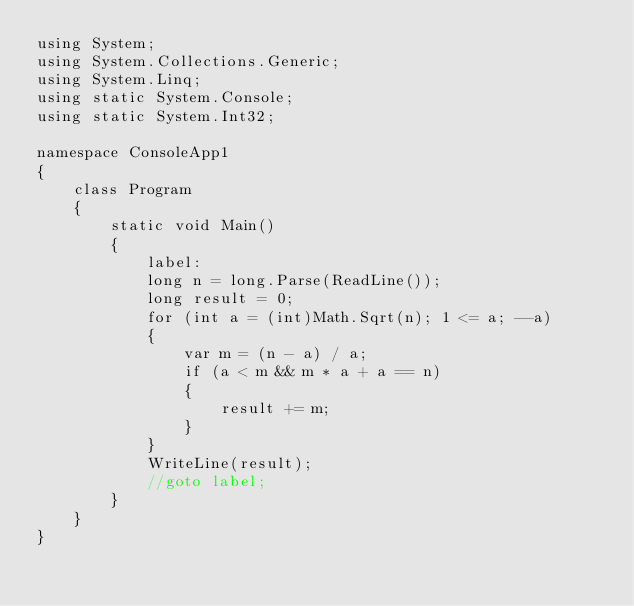<code> <loc_0><loc_0><loc_500><loc_500><_C#_>using System;
using System.Collections.Generic;
using System.Linq;
using static System.Console;
using static System.Int32;

namespace ConsoleApp1
{
    class Program
    {
        static void Main()
        {
            label:
            long n = long.Parse(ReadLine());
            long result = 0;
            for (int a = (int)Math.Sqrt(n); 1 <= a; --a)
            {
                var m = (n - a) / a;
                if (a < m && m * a + a == n)
                {
                    result += m;
                }
            }
            WriteLine(result);
            //goto label;
        }
    }
}
</code> 